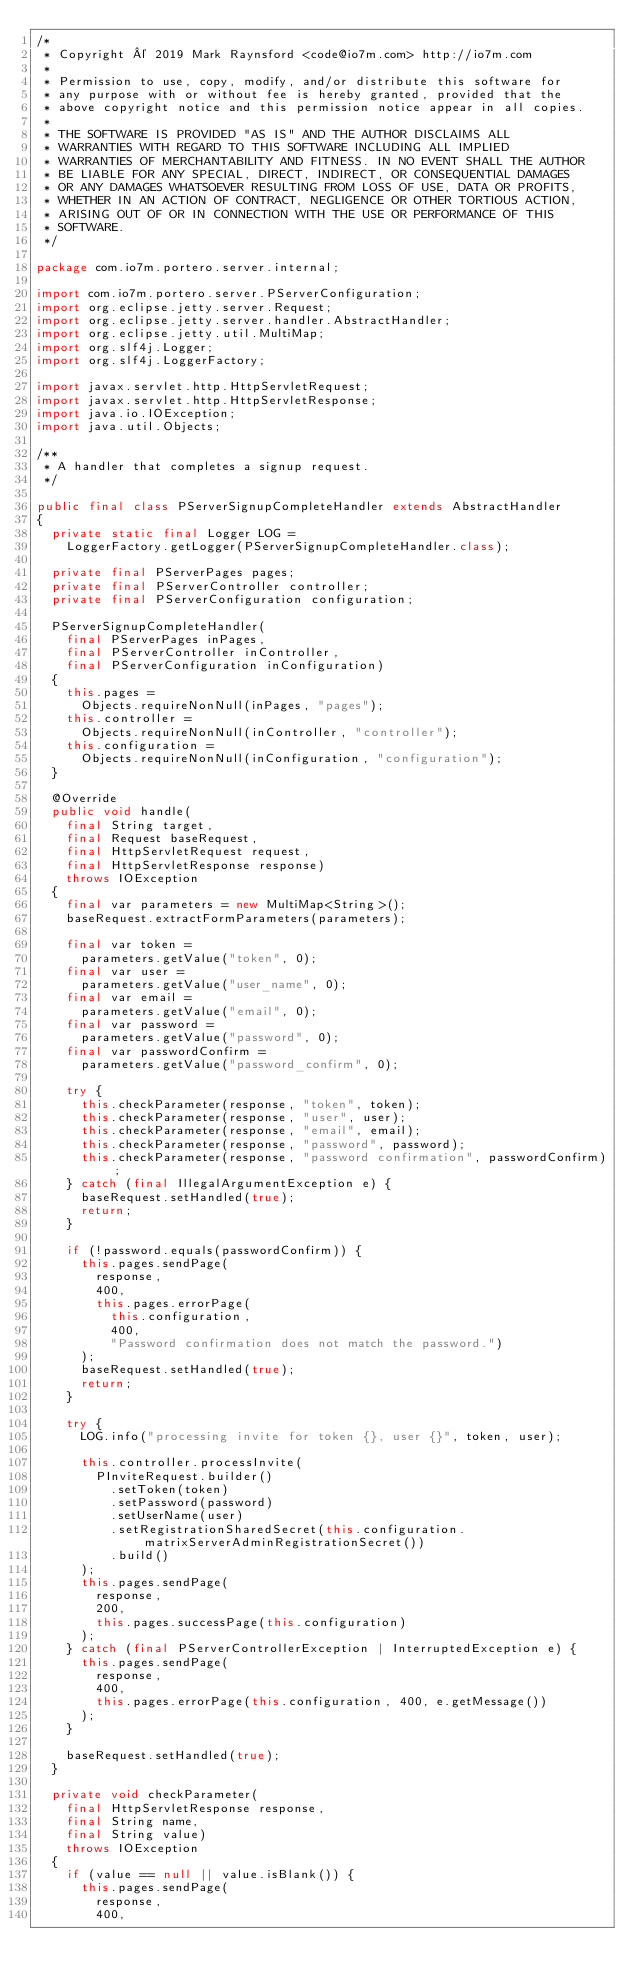<code> <loc_0><loc_0><loc_500><loc_500><_Java_>/*
 * Copyright © 2019 Mark Raynsford <code@io7m.com> http://io7m.com
 *
 * Permission to use, copy, modify, and/or distribute this software for
 * any purpose with or without fee is hereby granted, provided that the
 * above copyright notice and this permission notice appear in all copies.
 *
 * THE SOFTWARE IS PROVIDED "AS IS" AND THE AUTHOR DISCLAIMS ALL
 * WARRANTIES WITH REGARD TO THIS SOFTWARE INCLUDING ALL IMPLIED
 * WARRANTIES OF MERCHANTABILITY AND FITNESS. IN NO EVENT SHALL THE AUTHOR
 * BE LIABLE FOR ANY SPECIAL, DIRECT, INDIRECT, OR CONSEQUENTIAL DAMAGES
 * OR ANY DAMAGES WHATSOEVER RESULTING FROM LOSS OF USE, DATA OR PROFITS,
 * WHETHER IN AN ACTION OF CONTRACT, NEGLIGENCE OR OTHER TORTIOUS ACTION,
 * ARISING OUT OF OR IN CONNECTION WITH THE USE OR PERFORMANCE OF THIS
 * SOFTWARE.
 */

package com.io7m.portero.server.internal;

import com.io7m.portero.server.PServerConfiguration;
import org.eclipse.jetty.server.Request;
import org.eclipse.jetty.server.handler.AbstractHandler;
import org.eclipse.jetty.util.MultiMap;
import org.slf4j.Logger;
import org.slf4j.LoggerFactory;

import javax.servlet.http.HttpServletRequest;
import javax.servlet.http.HttpServletResponse;
import java.io.IOException;
import java.util.Objects;

/**
 * A handler that completes a signup request.
 */

public final class PServerSignupCompleteHandler extends AbstractHandler
{
  private static final Logger LOG =
    LoggerFactory.getLogger(PServerSignupCompleteHandler.class);

  private final PServerPages pages;
  private final PServerController controller;
  private final PServerConfiguration configuration;

  PServerSignupCompleteHandler(
    final PServerPages inPages,
    final PServerController inController,
    final PServerConfiguration inConfiguration)
  {
    this.pages =
      Objects.requireNonNull(inPages, "pages");
    this.controller =
      Objects.requireNonNull(inController, "controller");
    this.configuration =
      Objects.requireNonNull(inConfiguration, "configuration");
  }

  @Override
  public void handle(
    final String target,
    final Request baseRequest,
    final HttpServletRequest request,
    final HttpServletResponse response)
    throws IOException
  {
    final var parameters = new MultiMap<String>();
    baseRequest.extractFormParameters(parameters);

    final var token =
      parameters.getValue("token", 0);
    final var user =
      parameters.getValue("user_name", 0);
    final var email =
      parameters.getValue("email", 0);
    final var password =
      parameters.getValue("password", 0);
    final var passwordConfirm =
      parameters.getValue("password_confirm", 0);

    try {
      this.checkParameter(response, "token", token);
      this.checkParameter(response, "user", user);
      this.checkParameter(response, "email", email);
      this.checkParameter(response, "password", password);
      this.checkParameter(response, "password confirmation", passwordConfirm);
    } catch (final IllegalArgumentException e) {
      baseRequest.setHandled(true);
      return;
    }

    if (!password.equals(passwordConfirm)) {
      this.pages.sendPage(
        response,
        400,
        this.pages.errorPage(
          this.configuration,
          400,
          "Password confirmation does not match the password.")
      );
      baseRequest.setHandled(true);
      return;
    }

    try {
      LOG.info("processing invite for token {}, user {}", token, user);

      this.controller.processInvite(
        PInviteRequest.builder()
          .setToken(token)
          .setPassword(password)
          .setUserName(user)
          .setRegistrationSharedSecret(this.configuration.matrixServerAdminRegistrationSecret())
          .build()
      );
      this.pages.sendPage(
        response,
        200,
        this.pages.successPage(this.configuration)
      );
    } catch (final PServerControllerException | InterruptedException e) {
      this.pages.sendPage(
        response,
        400,
        this.pages.errorPage(this.configuration, 400, e.getMessage())
      );
    }

    baseRequest.setHandled(true);
  }

  private void checkParameter(
    final HttpServletResponse response,
    final String name,
    final String value)
    throws IOException
  {
    if (value == null || value.isBlank()) {
      this.pages.sendPage(
        response,
        400,</code> 